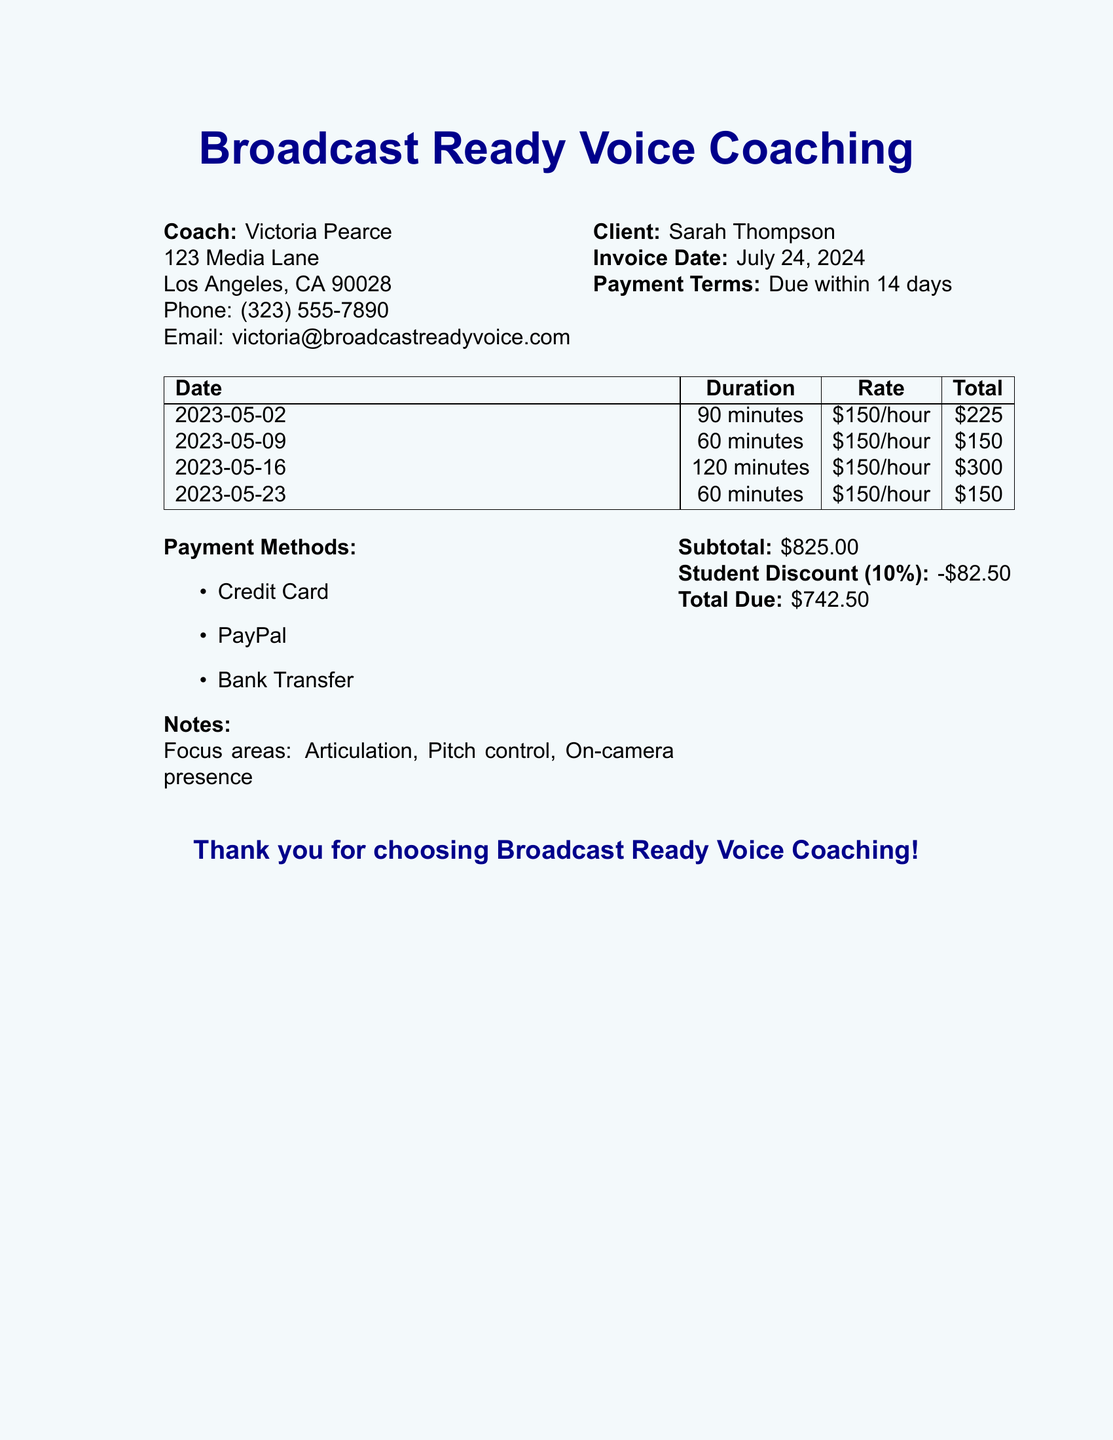what is the name of the coach? The coach's name is listed at the beginning of the document under the coach's information.
Answer: Victoria Pearce what is the total due amount? The total due amount is calculated at the end of the invoice.
Answer: $742.50 how many minutes was the longest coaching session? The duration of each session is listed in the table, and the longest session is the one with the highest duration.
Answer: 120 minutes what percentage is the student discount? The student discount is mentioned in the section detailing costs, showing a percentage off the subtotal.
Answer: 10% what is the email address of the coach? The email address of the coach is provided in the contact information.
Answer: victoria@broadcastreadyvoice.com what is the payment term specified in the document? The payment term is noted in the client section of the document.
Answer: Due within 14 days how many coaching sessions are listed in the document? The number of coaching sessions can be counted by checking the number of rows in the table.
Answer: 4 which payment method is not listed? The question pertains to payment options provided in the document, and any method not mentioned can be identified.
Answer: Cash 